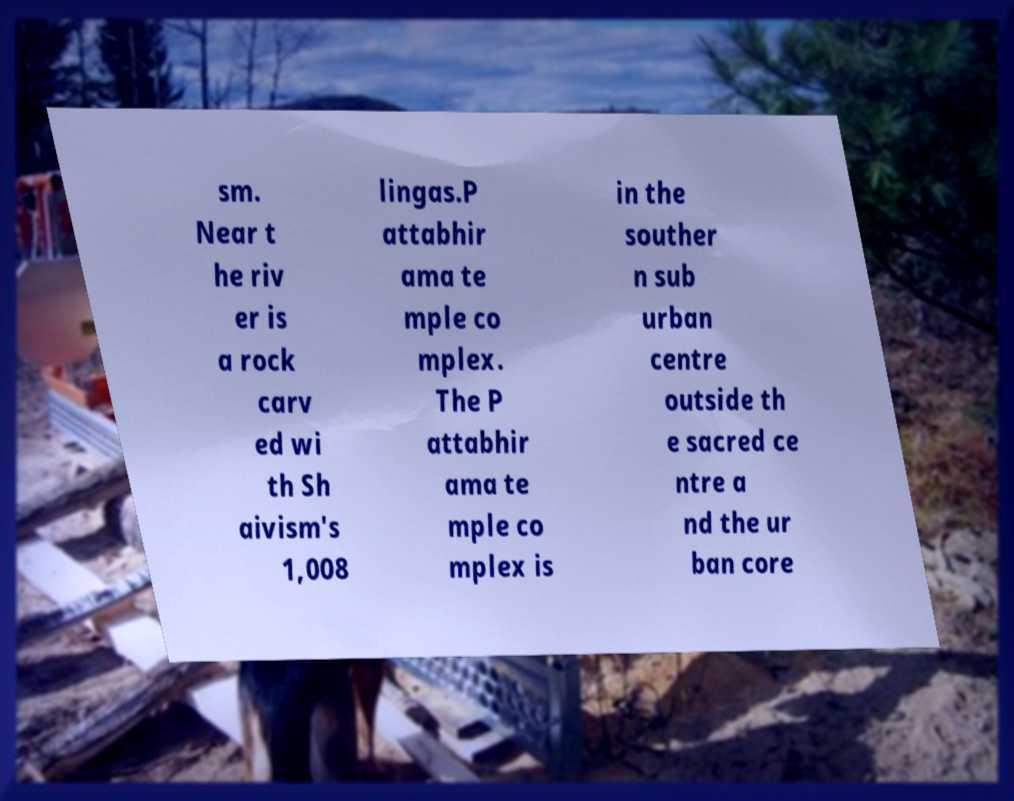For documentation purposes, I need the text within this image transcribed. Could you provide that? sm. Near t he riv er is a rock carv ed wi th Sh aivism's 1,008 lingas.P attabhir ama te mple co mplex. The P attabhir ama te mple co mplex is in the souther n sub urban centre outside th e sacred ce ntre a nd the ur ban core 